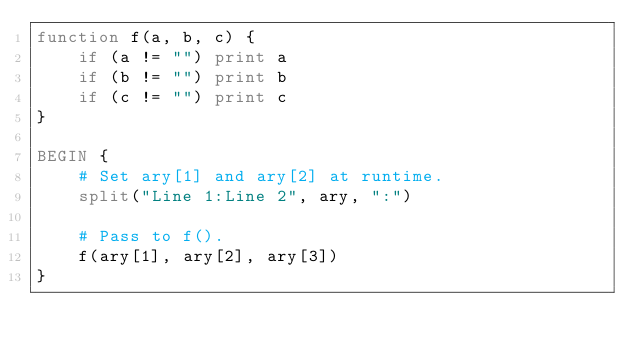Convert code to text. <code><loc_0><loc_0><loc_500><loc_500><_Awk_>function f(a, b, c) {
	if (a != "") print a
	if (b != "") print b
	if (c != "") print c
}

BEGIN {
	# Set ary[1] and ary[2] at runtime.
	split("Line 1:Line 2", ary, ":")

	# Pass to f().
	f(ary[1], ary[2], ary[3])
}
</code> 